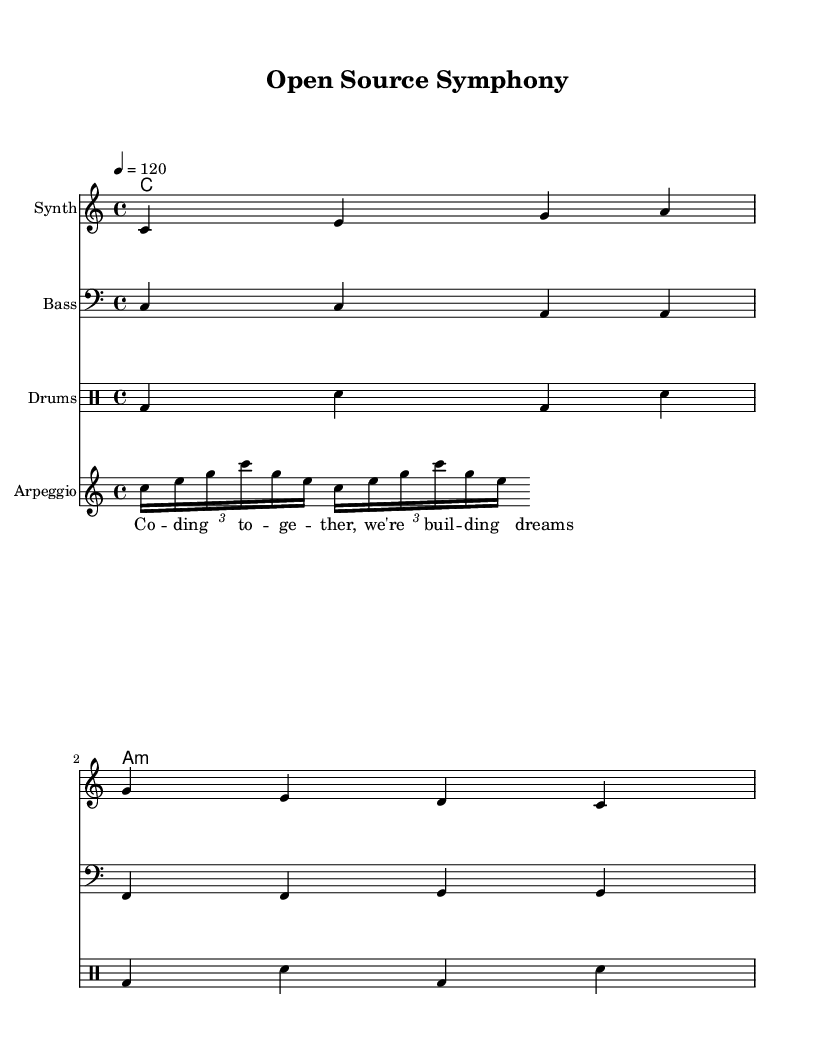What is the key signature of this music? The key signature is C major, which means there are no sharps or flats indicated on the staff.
Answer: C major What is the time signature of this music? The time signature shown is 4/4, which indicates that there are four beats in a measure and the quarter note gets one beat.
Answer: 4/4 What is the tempo marking for this piece? The tempo is indicated as "4 = 120," meaning that there are 120 beats per minute at the quarter note.
Answer: 120 How many measures are there in the melody? The melody consists of two measures that are clearly outlined by the bar lines.
Answer: 2 What is the instrument designated for the synth part? The instrument specifically named for the synth part is marked as "Synth" in the staff heading.
Answer: Synth How many different instrumental parts are depicted in the score? The score contains five different instrumental parts: Synth, Bass, Drums, and Arpeggio, along with the ChordNames.
Answer: 5 What is the primary theme expressed in the lyrics? The lyrics convey a collaborative spirit, focusing on building dreams together, which reflects the open-source collaboration theme.
Answer: Building dreams 